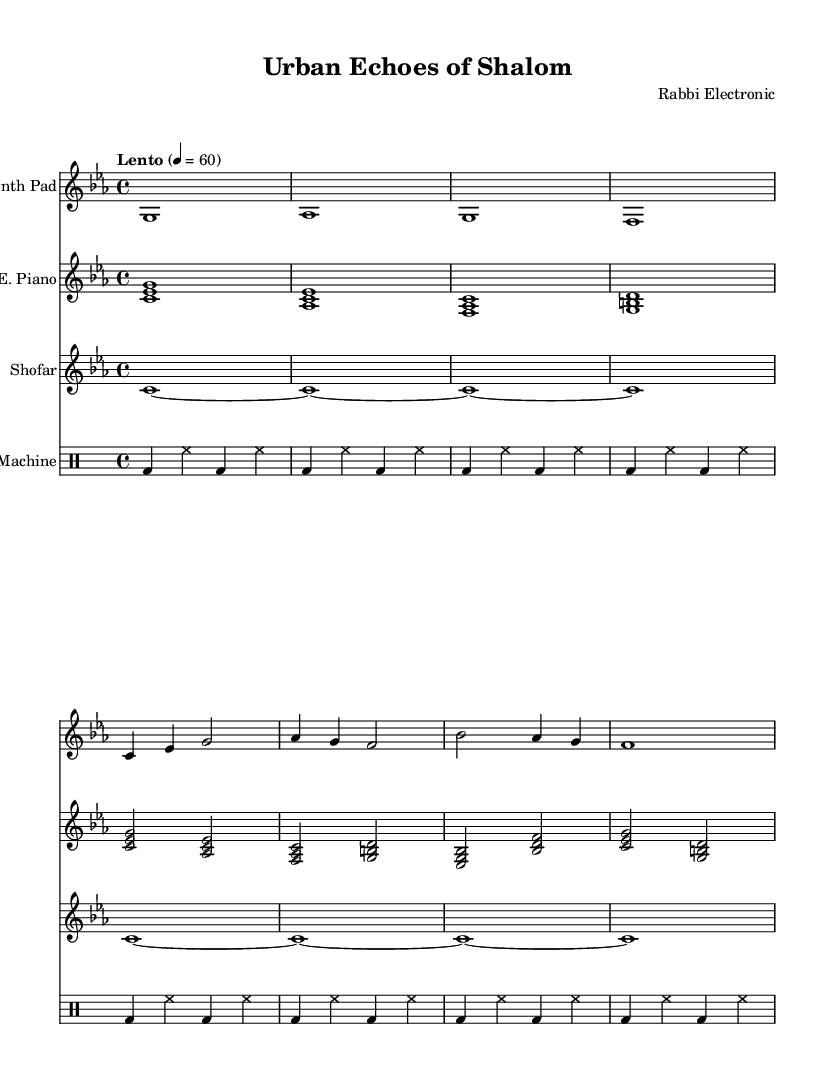What is the key signature of this music? The key signature is C minor, indicated by the three flats visible in the notation.
Answer: C minor What is the time signature of this piece? The time signature displayed in the sheet music is 4/4, known as common time, which allows for four beats per measure.
Answer: 4/4 What is the tempo marking of this composition? The tempo marking reads "Lento," which means to play slowly, along with the metronome marking of 60 beats per minute.
Answer: Lento How many measures are in the synth pad section? Counting the measures in the synth pad part, there are a total of 8 measures as indicated by the notation breaks.
Answer: 8 What instruments are included in this score? The score features four distinct instrument parts: Synth Pad, Electric Piano, Shofar, and Drum Machine, as labeled in the staff headings.
Answer: Synth Pad, Electric Piano, Shofar, Drum Machine Which rhythmic element predominantly appears in the drum machine part? The predominant rhythmic element in the drum machine part is the bass drum and hi-hat pattern, which repeats every measure, forming a foundational beat.
Answer: Bass drum and hi-hat What effect does the shofar sample have in this electronic piece? The shofar sample acts as a traditional sound that contrasts with the electronic elements, connecting the urban environment with cultural heritage.
Answer: Traditional contrast 